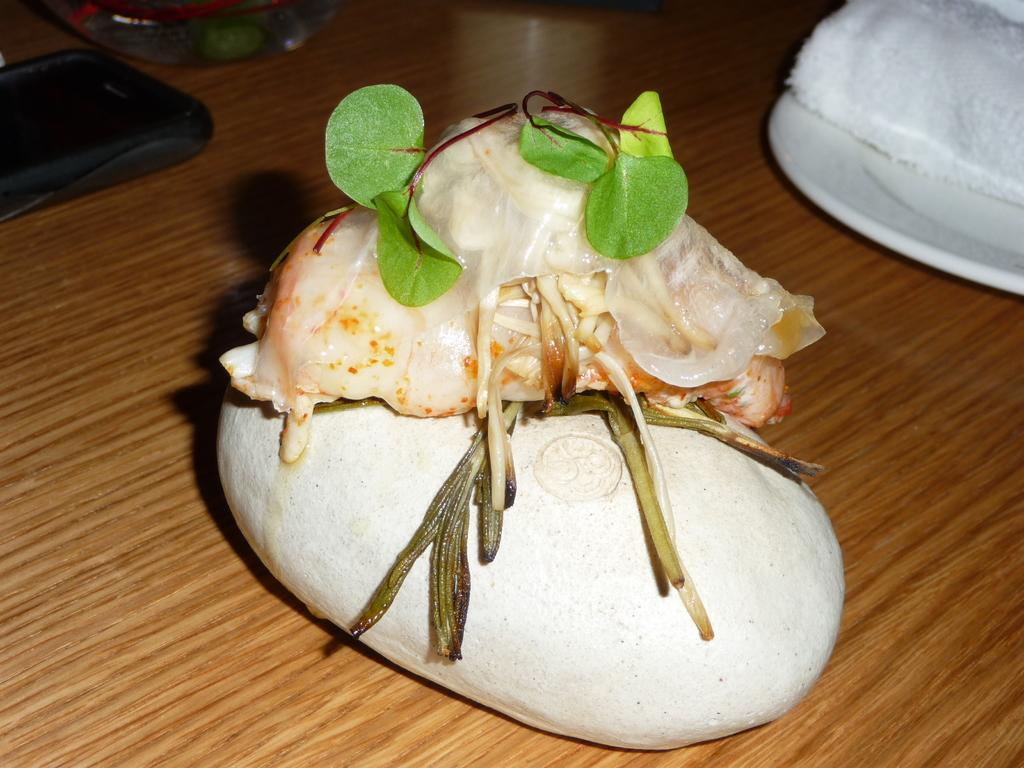What type of surface is the food and mobile phone resting on in the image? The food items and mobile phone are resting on a wooden table in the image. What other objects can be seen on the wooden table? There are additional objects on the wooden table, but their specific details are not mentioned in the provided facts. Can you describe the mobile phone in the image? The provided facts only mention that a mobile phone is present on the wooden table, but no further details about its appearance or condition are given. What advice does the grandmother give to the characters in the image? There is no mention of a grandmother or any characters in the image, so it is not possible to answer this question. 